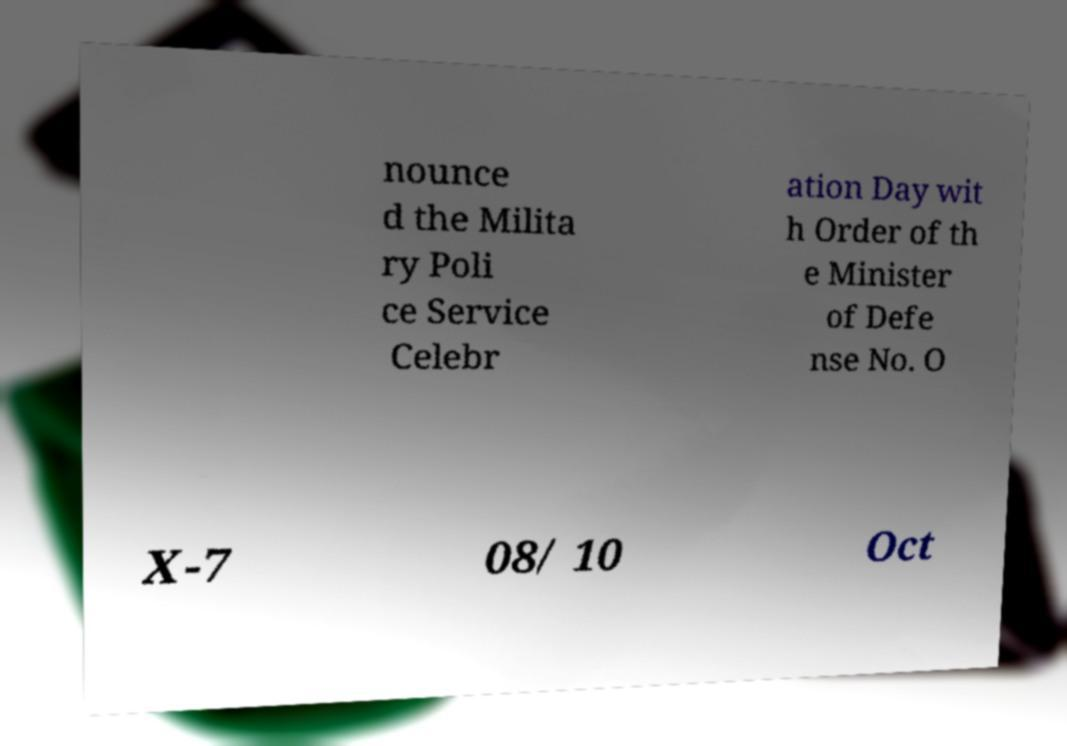There's text embedded in this image that I need extracted. Can you transcribe it verbatim? nounce d the Milita ry Poli ce Service Celebr ation Day wit h Order of th e Minister of Defe nse No. O X-7 08/ 10 Oct 